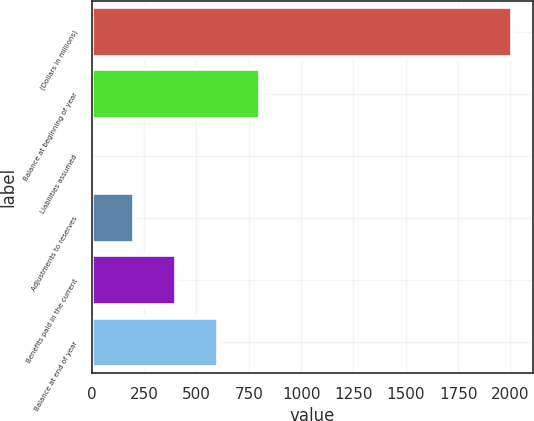Convert chart. <chart><loc_0><loc_0><loc_500><loc_500><bar_chart><fcel>(Dollars in millions)<fcel>Balance at beginning of year<fcel>Liabilities assumed<fcel>Adjustments to reserves<fcel>Benefits paid in the current<fcel>Balance at end of year<nl><fcel>2007<fcel>802.92<fcel>0.2<fcel>200.88<fcel>401.56<fcel>602.24<nl></chart> 